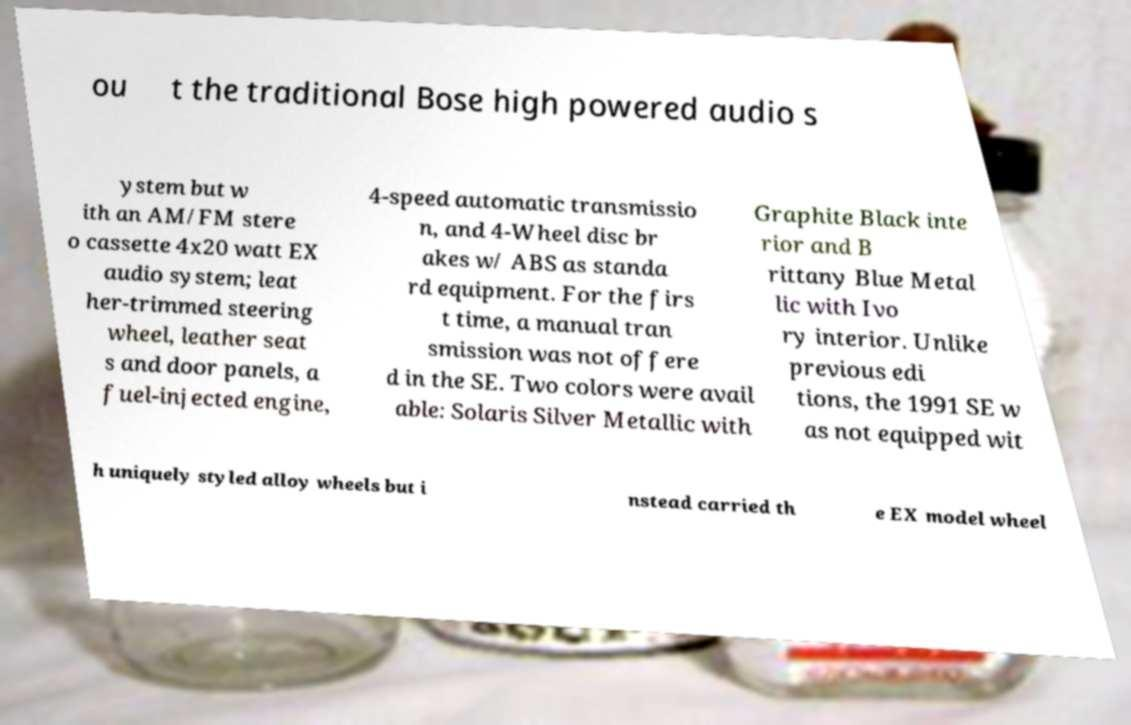Please read and relay the text visible in this image. What does it say? ou t the traditional Bose high powered audio s ystem but w ith an AM/FM stere o cassette 4x20 watt EX audio system; leat her-trimmed steering wheel, leather seat s and door panels, a fuel-injected engine, 4-speed automatic transmissio n, and 4-Wheel disc br akes w/ ABS as standa rd equipment. For the firs t time, a manual tran smission was not offere d in the SE. Two colors were avail able: Solaris Silver Metallic with Graphite Black inte rior and B rittany Blue Metal lic with Ivo ry interior. Unlike previous edi tions, the 1991 SE w as not equipped wit h uniquely styled alloy wheels but i nstead carried th e EX model wheel 